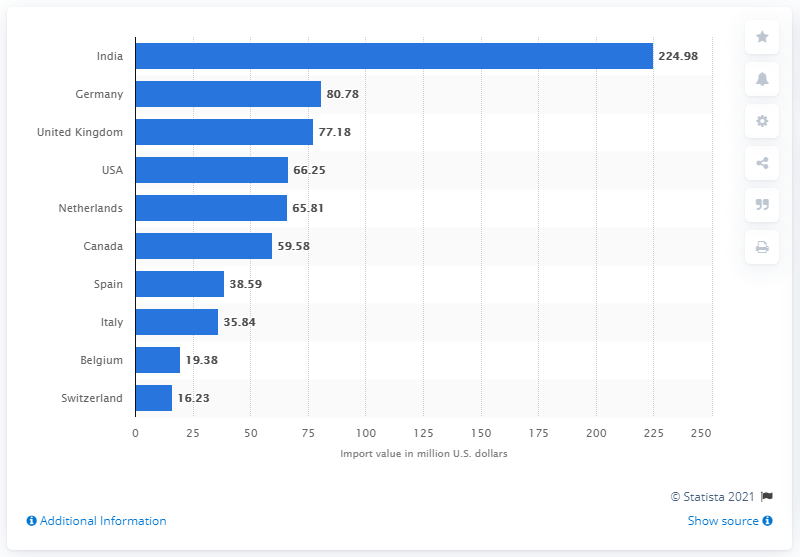Point out several critical features in this image. In 2020, the import value of India in dollars was 224.98. India was the largest importer of dates in 2020. 